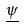Convert formula to latex. <formula><loc_0><loc_0><loc_500><loc_500>\underline { \psi }</formula> 